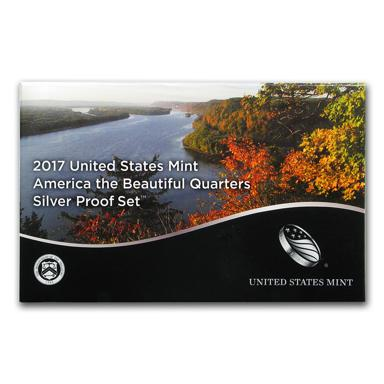Who issued the silver proof set? The silver proof set was issued by the United States Mint, a key governmental entity responsible for producing coinage for the United States to conduct its trade and commerce. The Mint's role is crucial in creating nationally significant and collectible sets like the one depicted, which also serve educational and commemorative purposes. 